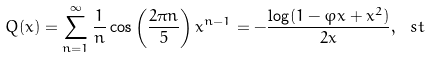<formula> <loc_0><loc_0><loc_500><loc_500>Q ( x ) = \sum _ { n = 1 } ^ { \infty } \frac { 1 } { n } \cos \left ( \frac { 2 \pi n } { 5 } \right ) x ^ { n - 1 } = - \frac { \log ( 1 - \varphi x + x ^ { 2 } ) } { 2 x } , \ s t</formula> 